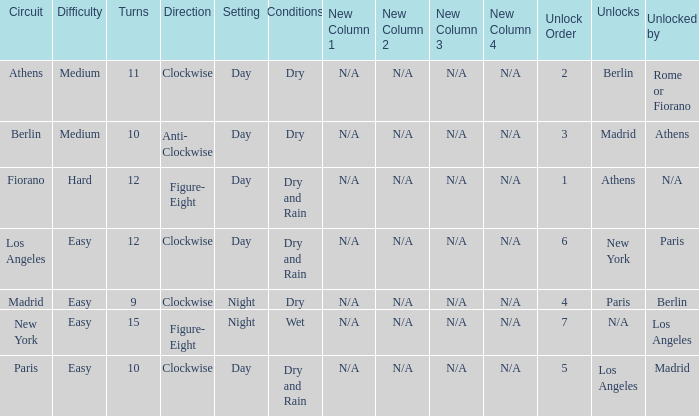How many instances is the unlocked n/a? 1.0. 